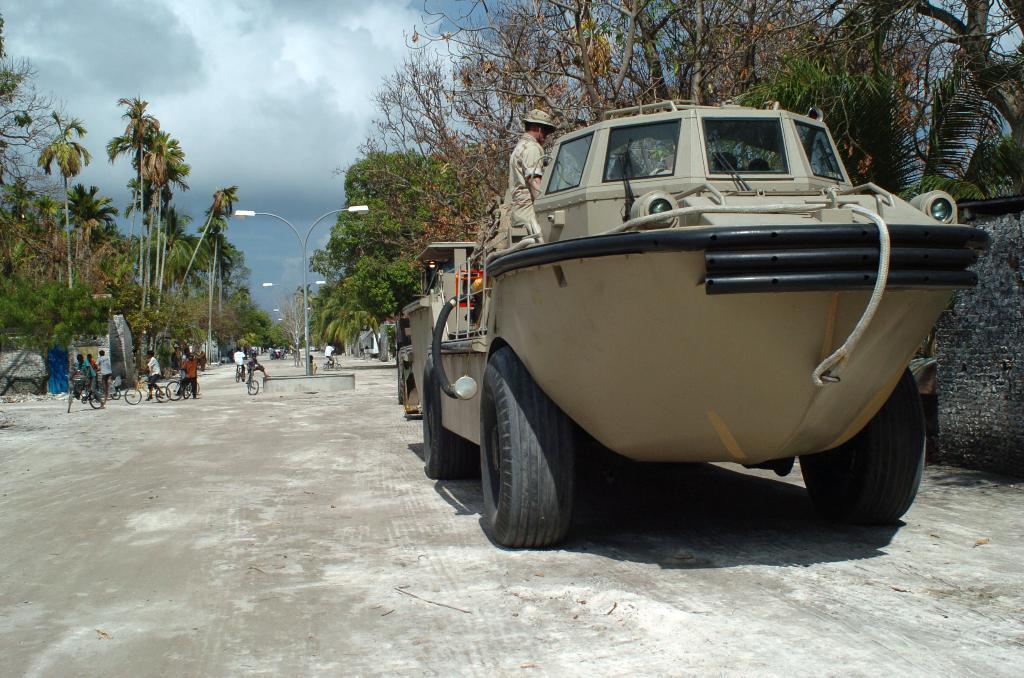What is happening in the image involving a person? There is a person in a vehicle in the image. What else can be seen on the road in the image? There are other vehicles on the road in the image. What can be seen in the distance in the image? There are trees and houses visible in the background of the image. Where is the cobweb located in the image? There is no cobweb present in the image. How does the pot affect the movement of the vehicles in the image? There is no pot present in the image, so it cannot affect the movement of the vehicles. 